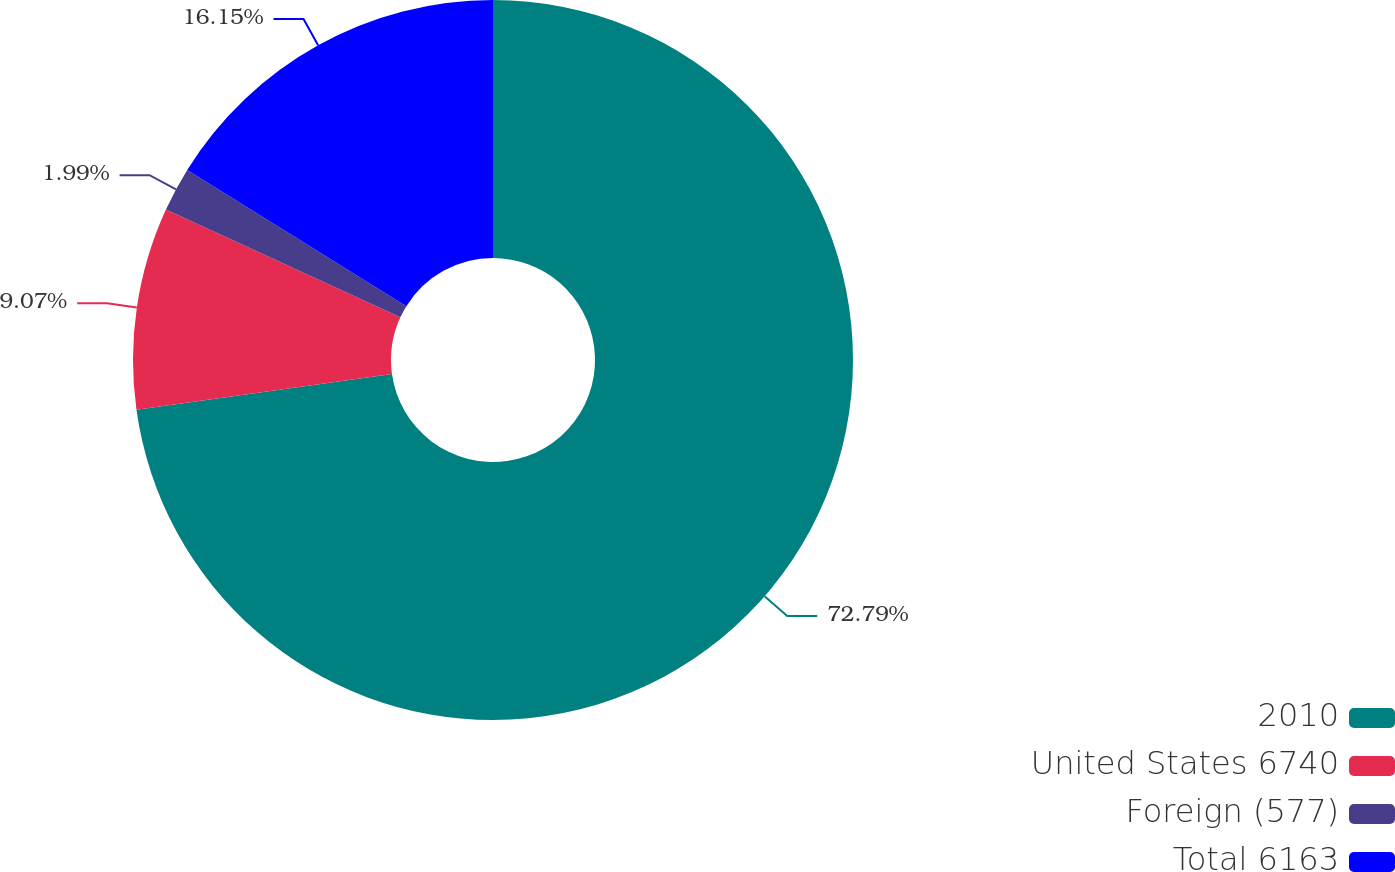Convert chart. <chart><loc_0><loc_0><loc_500><loc_500><pie_chart><fcel>2010<fcel>United States 6740<fcel>Foreign (577)<fcel>Total 6163<nl><fcel>72.8%<fcel>9.07%<fcel>1.99%<fcel>16.15%<nl></chart> 